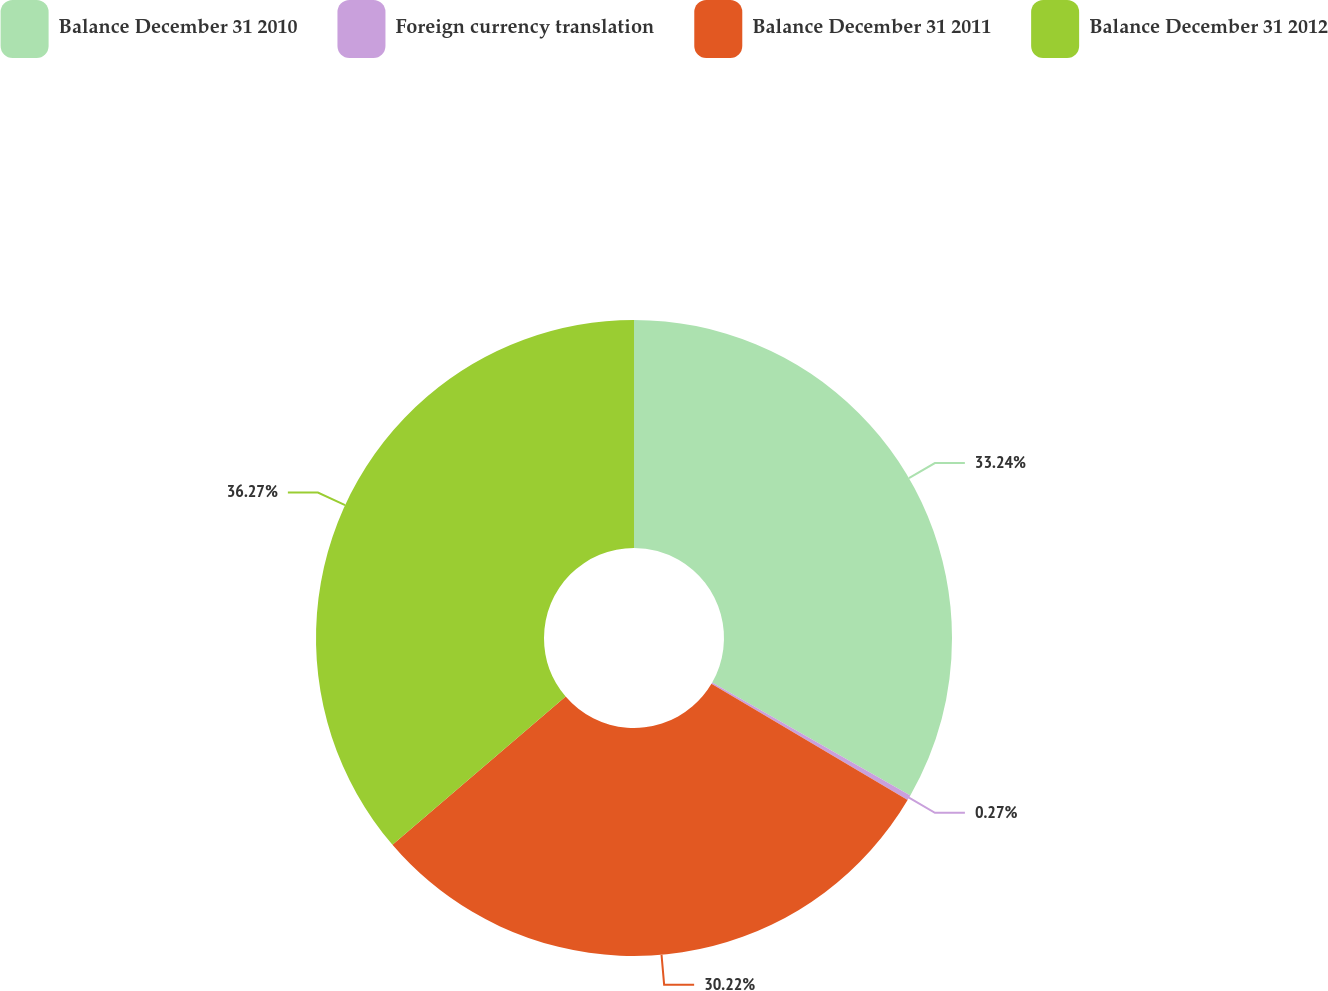Convert chart to OTSL. <chart><loc_0><loc_0><loc_500><loc_500><pie_chart><fcel>Balance December 31 2010<fcel>Foreign currency translation<fcel>Balance December 31 2011<fcel>Balance December 31 2012<nl><fcel>33.24%<fcel>0.27%<fcel>30.22%<fcel>36.27%<nl></chart> 